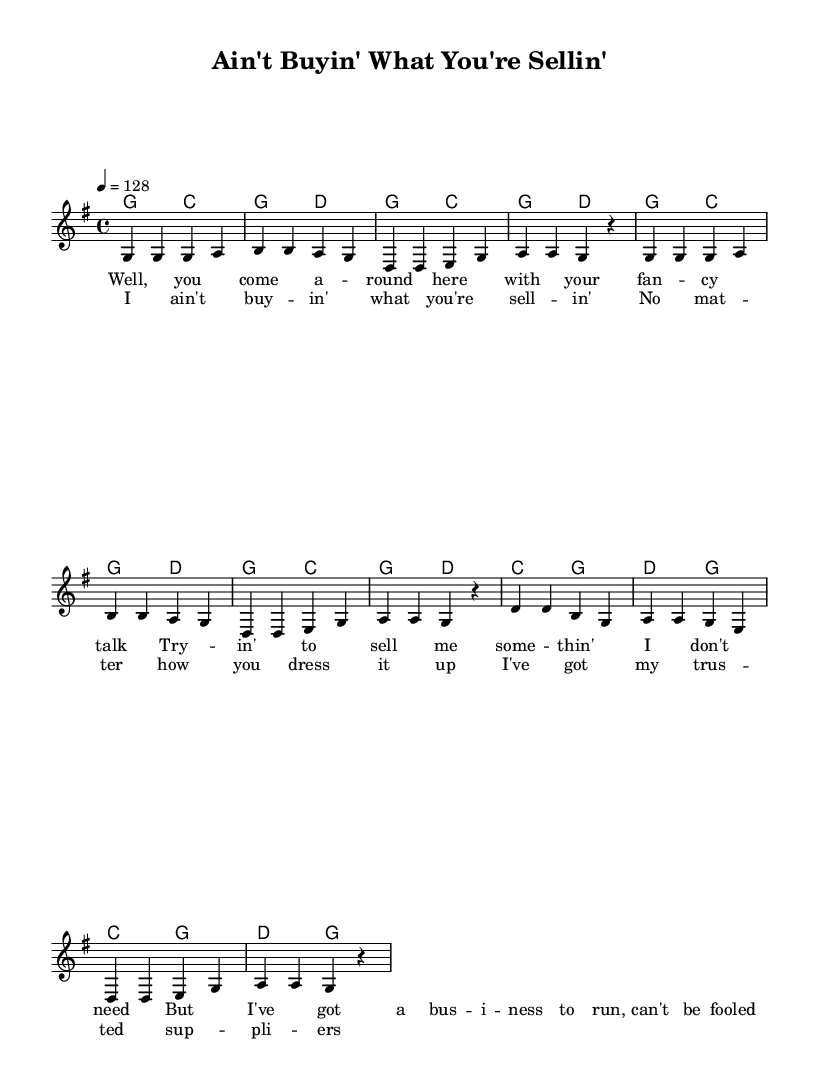What is the key signature of this music? The key signature is G major, which has one sharp (F#). This can be determined by looking at the key indication at the beginning of the sheet music, confirming it is G major.
Answer: G major What is the time signature of this piece? The time signature is 4/4, which is indicated at the beginning of the sheet music. This means there are four beats in each measure and the quarter note receives one beat.
Answer: 4/4 What is the tempo marking for the piece? The tempo marking is 128 beats per minute, as suggested by "4 = 128" in the global music settings. This indicates a moderate upbeat pace for the music.
Answer: 128 How many measures are in the verse section? The verse section contains 4 measures, which can be counted by examining the melody and corresponding lyrics together.
Answer: 4 What musical form is used in this piece? The form used in this piece is verse-chorus, which is common in country music. This can be deduced from the presence of distinct verse and chorus sections in the lyrics.
Answer: verse-chorus Which chord is found in the first measure? The chord in the first measure is G major, as indicated in the harmonies section directly above the melody, showing the corresponding chord played with the melody notes.
Answer: G What is the theme of the lyrics in this song? The theme of the lyrics focuses on resisting pushy salesmen and maintaining trust in one's suppliers, which is evident in the text describing the interaction with a salesman.
Answer: Trust in suppliers 